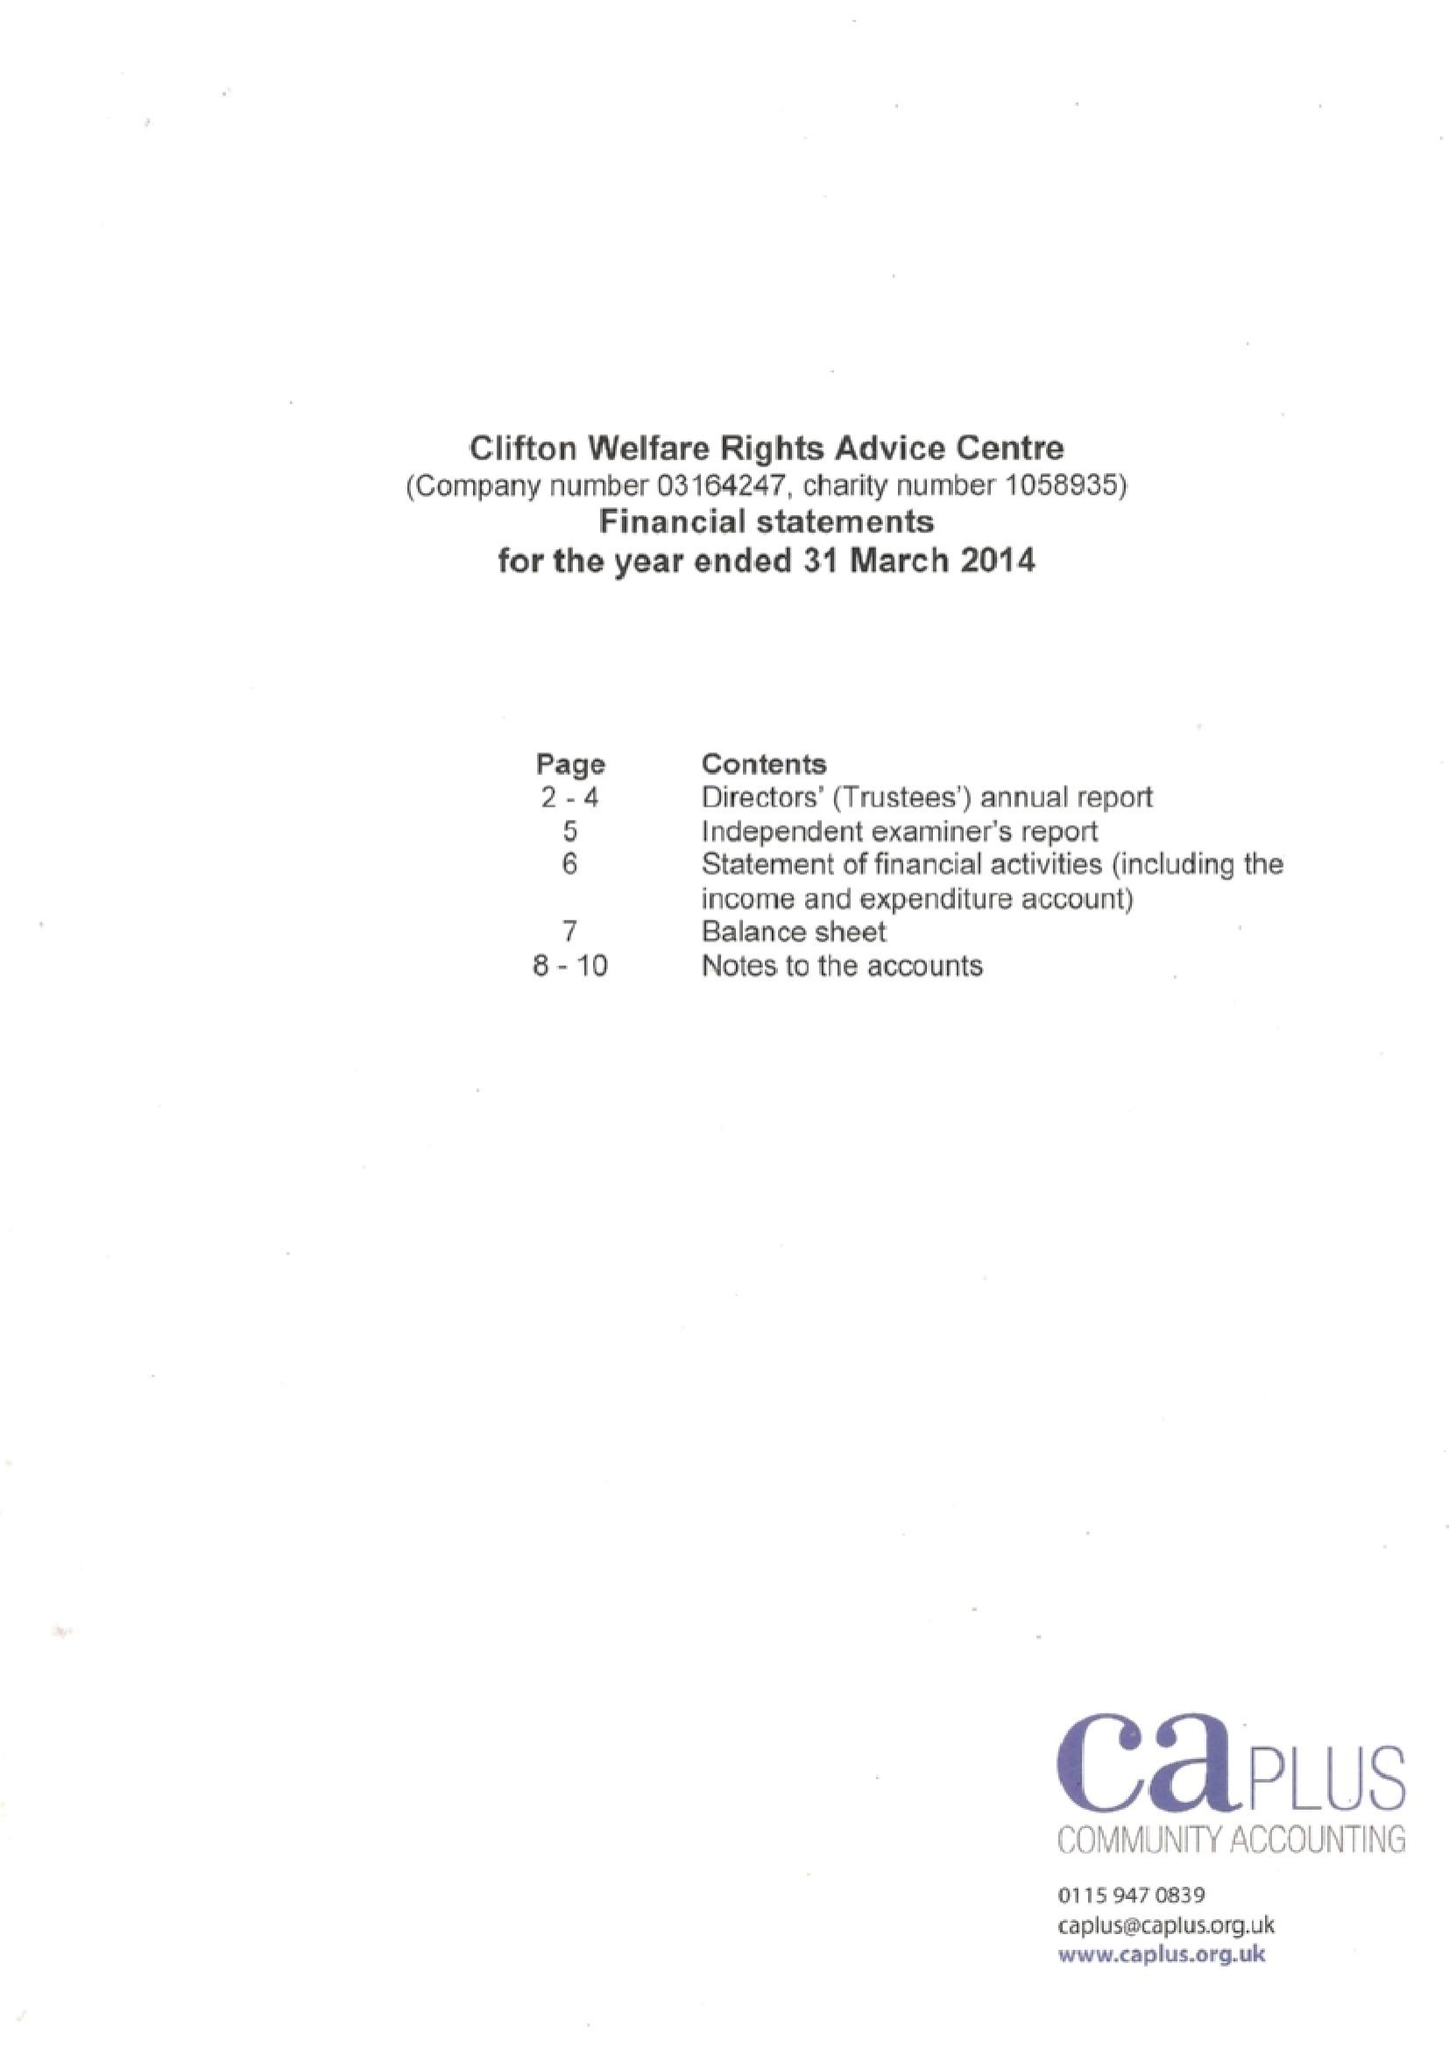What is the value for the charity_number?
Answer the question using a single word or phrase. 1058935 